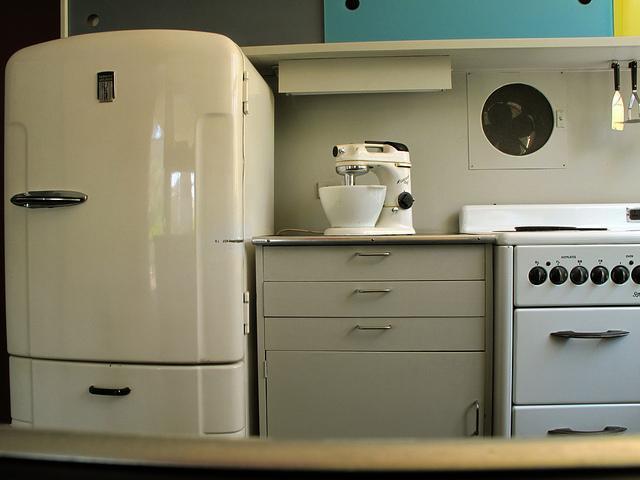How many jobs are on the stove?
Give a very brief answer. 6. How many cars are in front of the motorcycle?
Give a very brief answer. 0. 